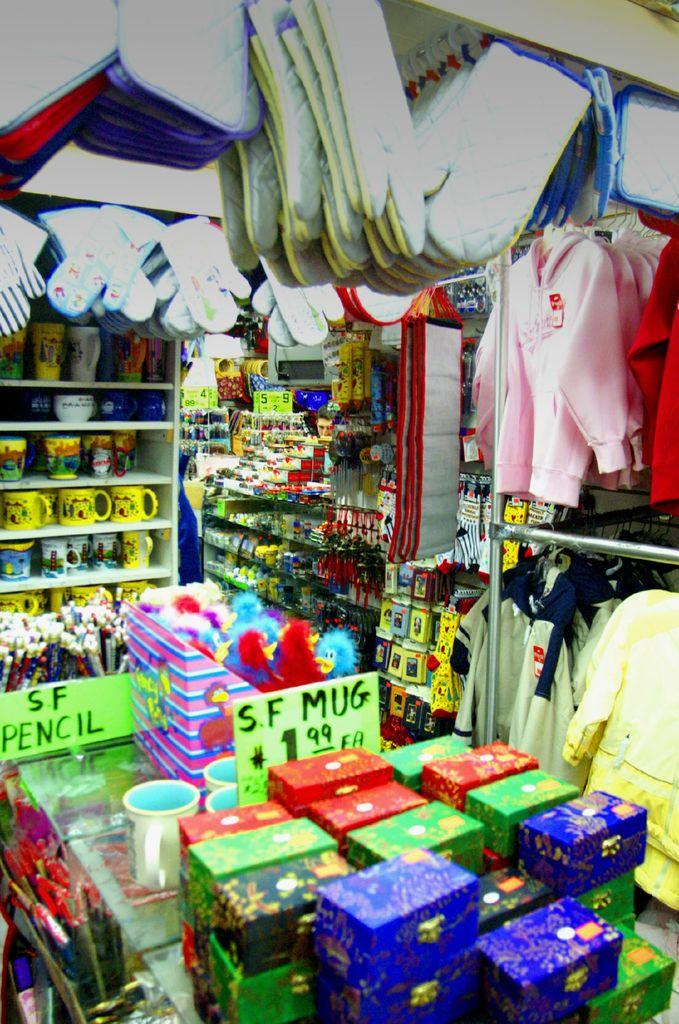Provide a one-sentence caption for the provided image. The shop is full of nice nick nacks to buy. 